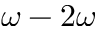<formula> <loc_0><loc_0><loc_500><loc_500>\omega - 2 \omega</formula> 